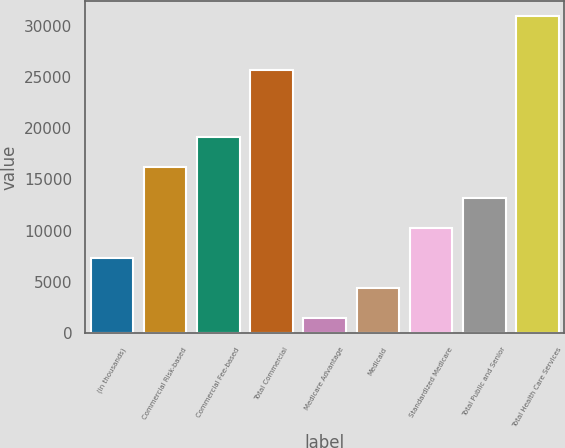Convert chart. <chart><loc_0><loc_0><loc_500><loc_500><bar_chart><fcel>(in thousands)<fcel>Commercial Risk-based<fcel>Commercial Fee-based<fcel>Total Commercial<fcel>Medicare Advantage<fcel>Medicaid<fcel>Standardized Medicare<fcel>Total Public and Senior<fcel>Total Health Care Services<nl><fcel>7333<fcel>16165<fcel>19109<fcel>25700<fcel>1445<fcel>4389<fcel>10277<fcel>13221<fcel>30885<nl></chart> 